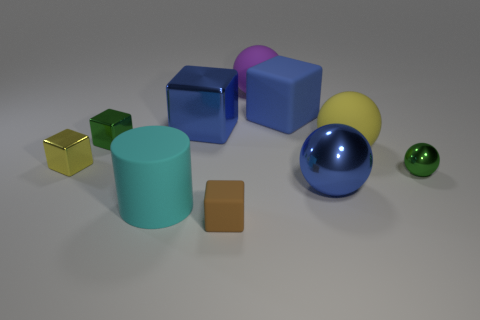Subtract all yellow cubes. How many cubes are left? 4 Subtract all big blue shiny blocks. How many blocks are left? 4 Subtract 1 cubes. How many cubes are left? 4 Subtract all red cubes. Subtract all green cylinders. How many cubes are left? 5 Subtract all balls. How many objects are left? 6 Add 8 purple matte objects. How many purple matte objects exist? 9 Subtract 1 blue blocks. How many objects are left? 9 Subtract all large matte blocks. Subtract all purple matte balls. How many objects are left? 8 Add 8 tiny green metallic objects. How many tiny green metallic objects are left? 10 